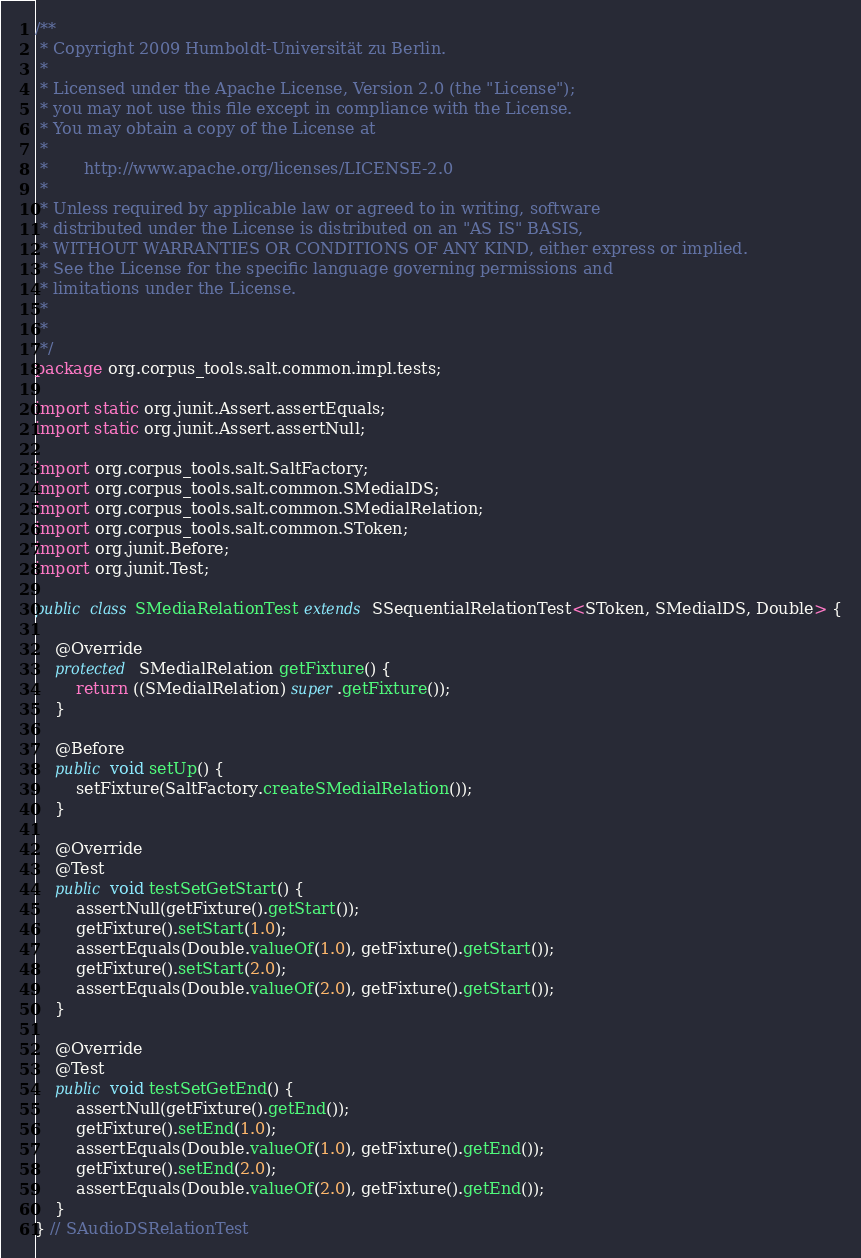Convert code to text. <code><loc_0><loc_0><loc_500><loc_500><_Java_>/**
 * Copyright 2009 Humboldt-Universität zu Berlin.
 *
 * Licensed under the Apache License, Version 2.0 (the "License");
 * you may not use this file except in compliance with the License.
 * You may obtain a copy of the License at
 *
 *       http://www.apache.org/licenses/LICENSE-2.0
 *
 * Unless required by applicable law or agreed to in writing, software
 * distributed under the License is distributed on an "AS IS" BASIS,
 * WITHOUT WARRANTIES OR CONDITIONS OF ANY KIND, either express or implied.
 * See the License for the specific language governing permissions and
 * limitations under the License.
 *
 *
 */
package org.corpus_tools.salt.common.impl.tests;

import static org.junit.Assert.assertEquals;
import static org.junit.Assert.assertNull;

import org.corpus_tools.salt.SaltFactory;
import org.corpus_tools.salt.common.SMedialDS;
import org.corpus_tools.salt.common.SMedialRelation;
import org.corpus_tools.salt.common.SToken;
import org.junit.Before;
import org.junit.Test;

public class SMediaRelationTest extends SSequentialRelationTest<SToken, SMedialDS, Double> {

	@Override
	protected SMedialRelation getFixture() {
		return ((SMedialRelation) super.getFixture());
	}

	@Before
	public void setUp() {
		setFixture(SaltFactory.createSMedialRelation());
	}

	@Override
	@Test
	public void testSetGetStart() {
		assertNull(getFixture().getStart());
		getFixture().setStart(1.0);
		assertEquals(Double.valueOf(1.0), getFixture().getStart());
		getFixture().setStart(2.0);
		assertEquals(Double.valueOf(2.0), getFixture().getStart());
	}

	@Override
	@Test
	public void testSetGetEnd() {
		assertNull(getFixture().getEnd());
		getFixture().setEnd(1.0);
		assertEquals(Double.valueOf(1.0), getFixture().getEnd());
		getFixture().setEnd(2.0);
		assertEquals(Double.valueOf(2.0), getFixture().getEnd());
	}
} // SAudioDSRelationTest
</code> 